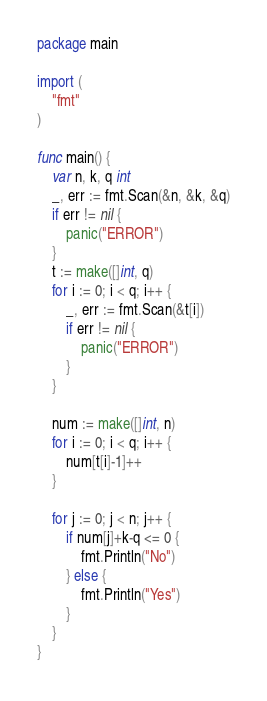Convert code to text. <code><loc_0><loc_0><loc_500><loc_500><_Go_>package main

import (
	"fmt"
)

func main() {
	var n, k, q int
	_, err := fmt.Scan(&n, &k, &q)
	if err != nil {
		panic("ERROR")
	}
	t := make([]int, q)
	for i := 0; i < q; i++ {
		_, err := fmt.Scan(&t[i])
        if err != nil {
            panic("ERROR")
        }
	}

	num := make([]int, n)
	for i := 0; i < q; i++ {
		num[t[i]-1]++
	}

	for j := 0; j < n; j++ {
		if num[j]+k-q <= 0 {
			fmt.Println("No")
		} else {
			fmt.Println("Yes")
		}
	}
}</code> 